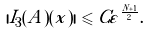Convert formula to latex. <formula><loc_0><loc_0><loc_500><loc_500>| I _ { 3 } ( A ) ( x ) | \leqslant C \varepsilon ^ { \frac { N + 1 } { 2 } } .</formula> 